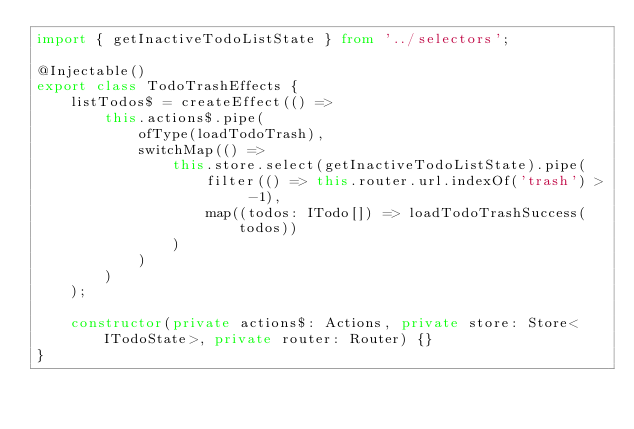<code> <loc_0><loc_0><loc_500><loc_500><_TypeScript_>import { getInactiveTodoListState } from '../selectors';

@Injectable()
export class TodoTrashEffects {
    listTodos$ = createEffect(() =>
        this.actions$.pipe(
            ofType(loadTodoTrash),
            switchMap(() =>
                this.store.select(getInactiveTodoListState).pipe(
                    filter(() => this.router.url.indexOf('trash') > -1),
                    map((todos: ITodo[]) => loadTodoTrashSuccess(todos))
                )
            )
        )
    );

    constructor(private actions$: Actions, private store: Store<ITodoState>, private router: Router) {}
}
</code> 